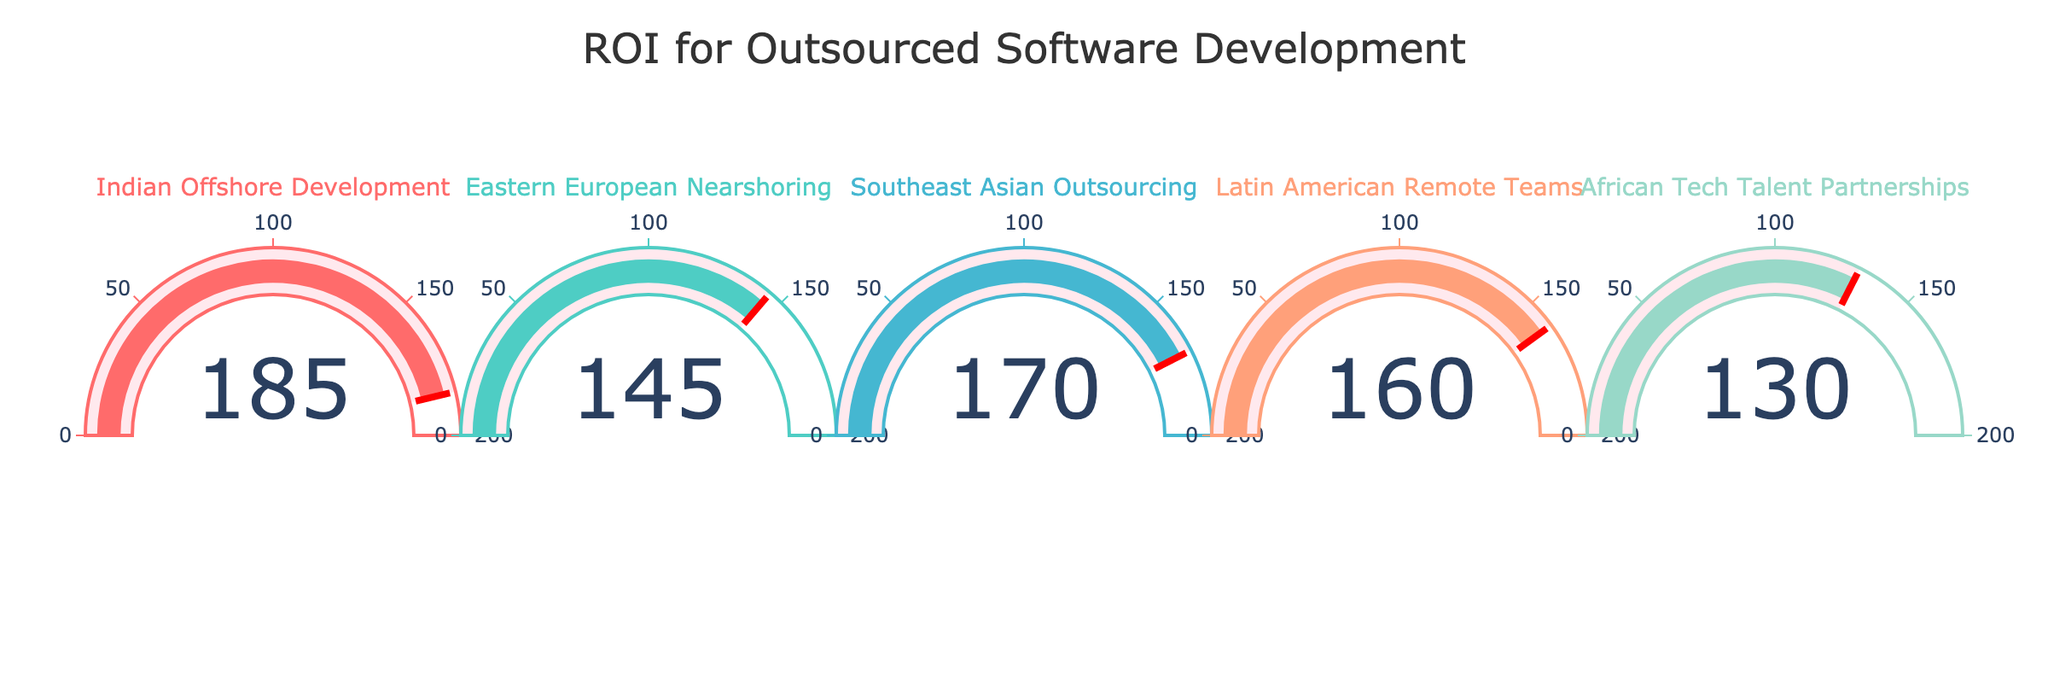What is the title of the figure? The title of the figure is displayed at the top and centrally aligned. It reads "ROI for Outsourced Software Development".
Answer: ROI for Outsourced Software Development How many projects are shown in the figure? The total number of projects is indicated by the number of gauges in the figure. Counting the gauges reveals there are 5 projects displayed.
Answer: 5 Which project has the highest ROI? By observing the gauge values, the project with the highest ROI is "Indian Offshore Development," which shows a value of 185.
Answer: Indian Offshore Development Which color is used for the "Latin American Remote Teams" project? Each project is marked with a different color. The "Latin American Remote Teams" project is represented with a shade of light salmon.
Answer: Light Salmon What is the ROI value for the "African Tech Talent Partnerships"? The gauge for the "African Tech Talent Partnerships" project displays an ROI value of 130.
Answer: 130 What is the average ROI value across all projects? The ROI values are summed up: 185 (Indian Offshore Development) + 145 (Eastern European Nearshoring) + 170 (Southeast Asian Outsourcing) + 160 (Latin American Remote Teams) + 130 (African Tech Talent Partnerships) = 790. The average is calculated by dividing by the number of projects (5): 790 / 5 = 158.
Answer: 158 What is the difference in ROI between the highest and lowest projects? The highest ROI is 185 (Indian Offshore Development) and the lowest is 130 (African Tech Talent Partnerships). The difference is calculated as 185 - 130 = 55.
Answer: 55 Which project is in the middle in terms of ROI? Order the ROI values: 130, 145, 160, 170, 185. The middle value is 160, which corresponds to the "Latin American Remote Teams" project.
Answer: Latin American Remote Teams Is the ROI of "Southeast Asian Outsourcing" greater than or equal to 170? The ROI value for "Southeast Asian Outsourcing" is directly shown on its gauge and reads 170. Since 170 is equal to 170, the condition is satisfied.
Answer: Yes 